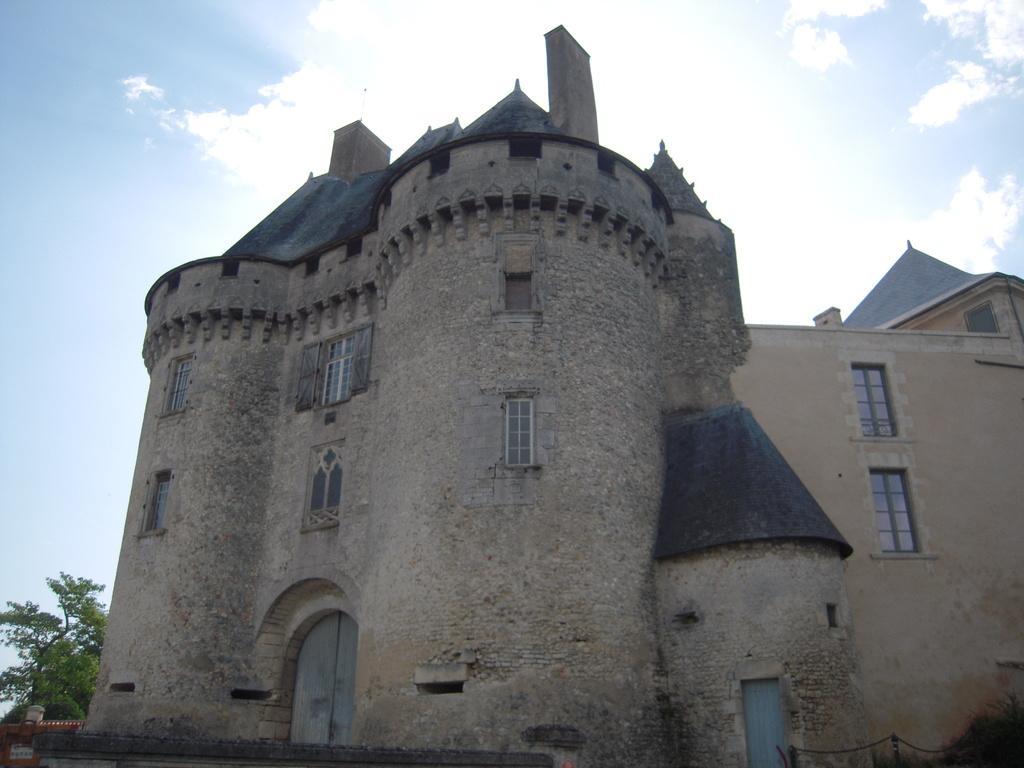Describe this image in one or two sentences. In this picture, we see a castle and we see the doors and the windows. In the right bottom, we see the grass and the poles. In the left bottom, we see the trees and a building in brown color. At the top, we see the sky and the clouds. 